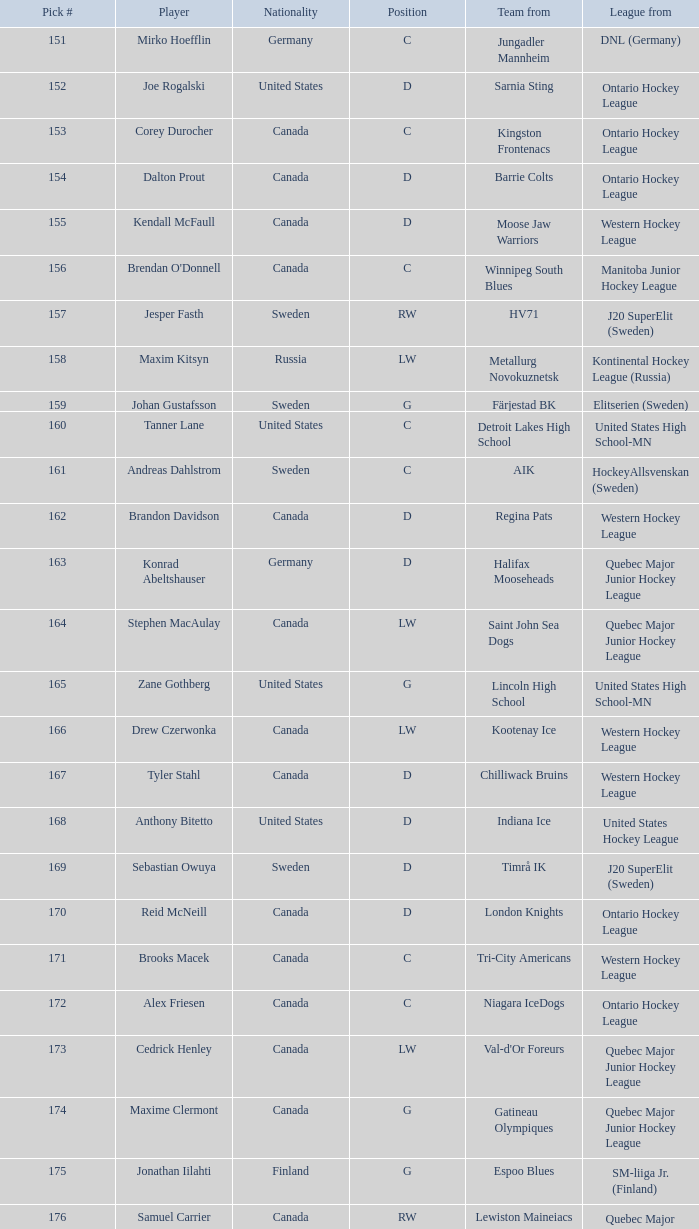For samuel carrier, a quebec major junior hockey league player, what is the average draft position? 176.0. 